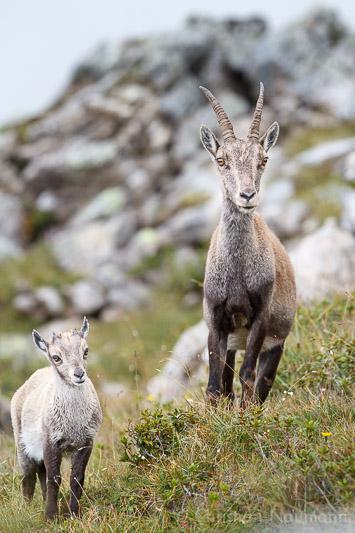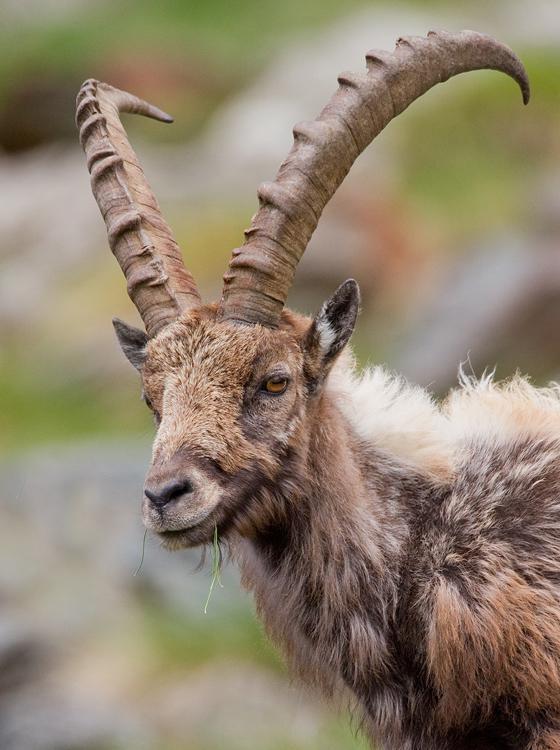The first image is the image on the left, the second image is the image on the right. Given the left and right images, does the statement "One image shows two antelope, which are not butting heads." hold true? Answer yes or no. Yes. 